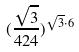Convert formula to latex. <formula><loc_0><loc_0><loc_500><loc_500>( \frac { \sqrt { 3 } } { 4 2 4 } ) ^ { \sqrt { 3 } \cdot 6 }</formula> 